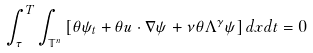<formula> <loc_0><loc_0><loc_500><loc_500>\int ^ { T } _ { \tau } \int _ { \mathbb { T } ^ { n } } \left [ \theta \psi _ { t } + \theta u \cdot \nabla \psi + \nu \theta \Lambda ^ { \gamma } \psi \right ] d x d t = 0</formula> 